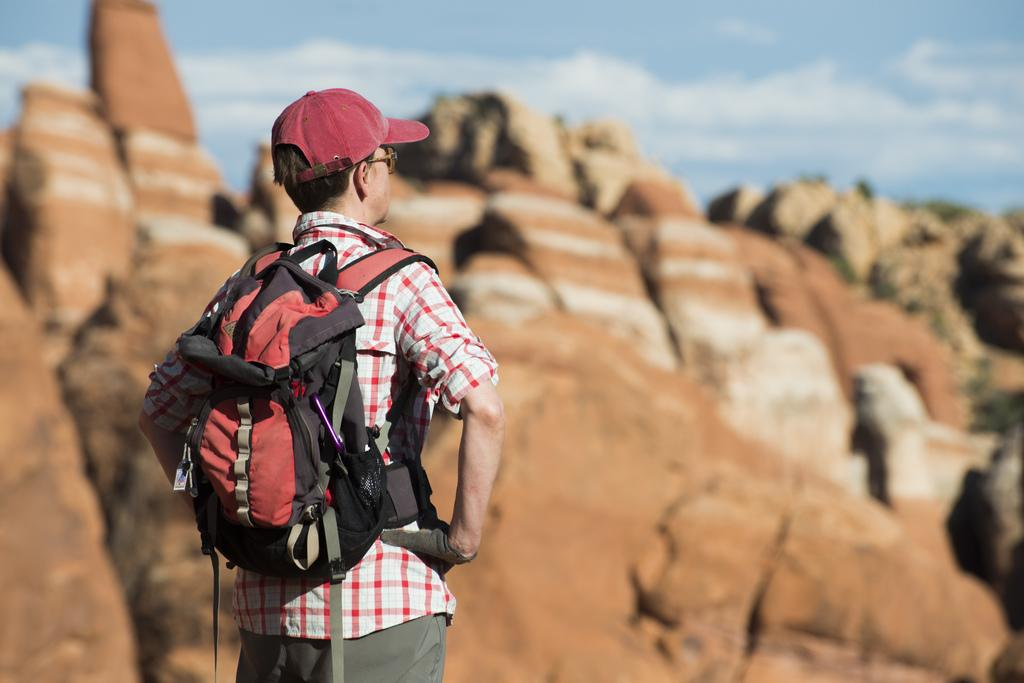What is the main subject of the image? There is a man in the image. What is the man doing in the image? The man is standing. What is the man carrying in the image? The man is wearing a backpack. Can you describe the quality of the image? The front of the image is blurry. How many crates are being carried by the man in the image? There are no crates present in the image; the man is wearing a backpack. What type of flock can be seen flying in the background of the image? There is no flock visible in the image; the background is not described in the provided facts. 